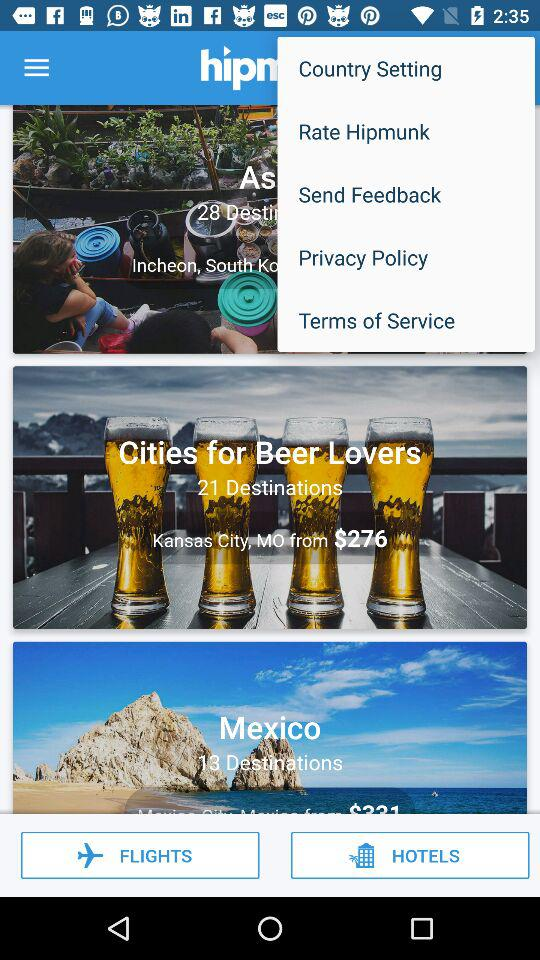How many destinations are there in "Cities for Beer Lovers"? There are 21 destinations in "Cities for Beer Lovers". 